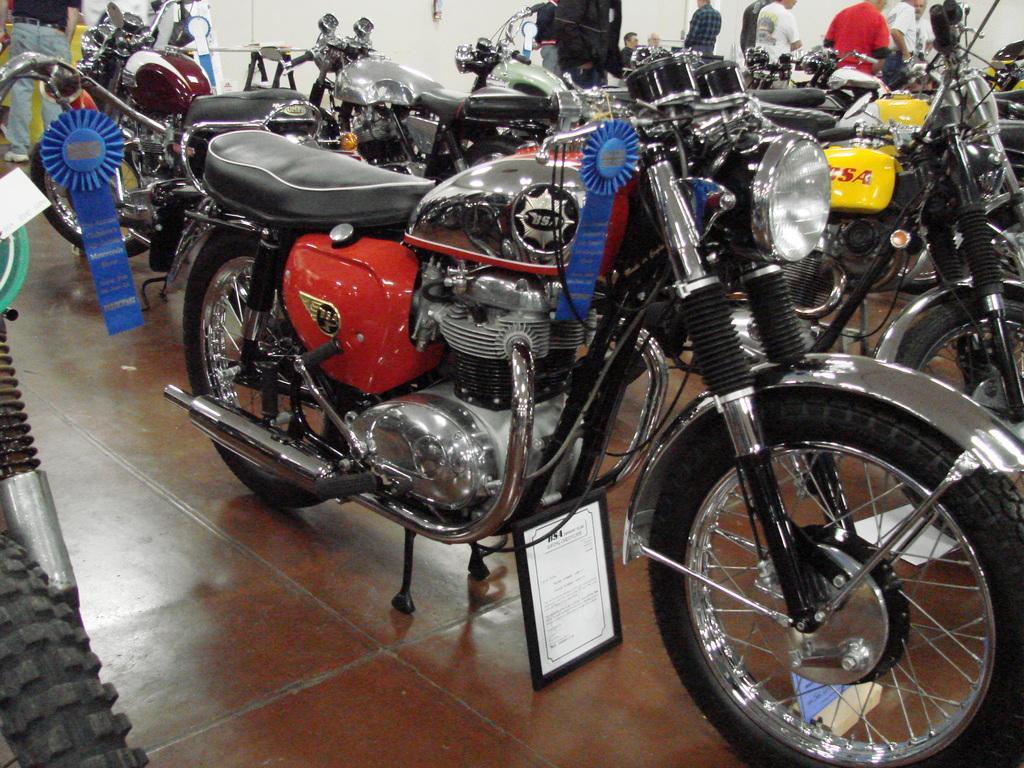Can you describe this image briefly? In this image there are a few bikes on the display, under the bike there is a photo frame with some text on it, behind the bikes there are a few people standing, behind them there are some objects and there is a wall. 